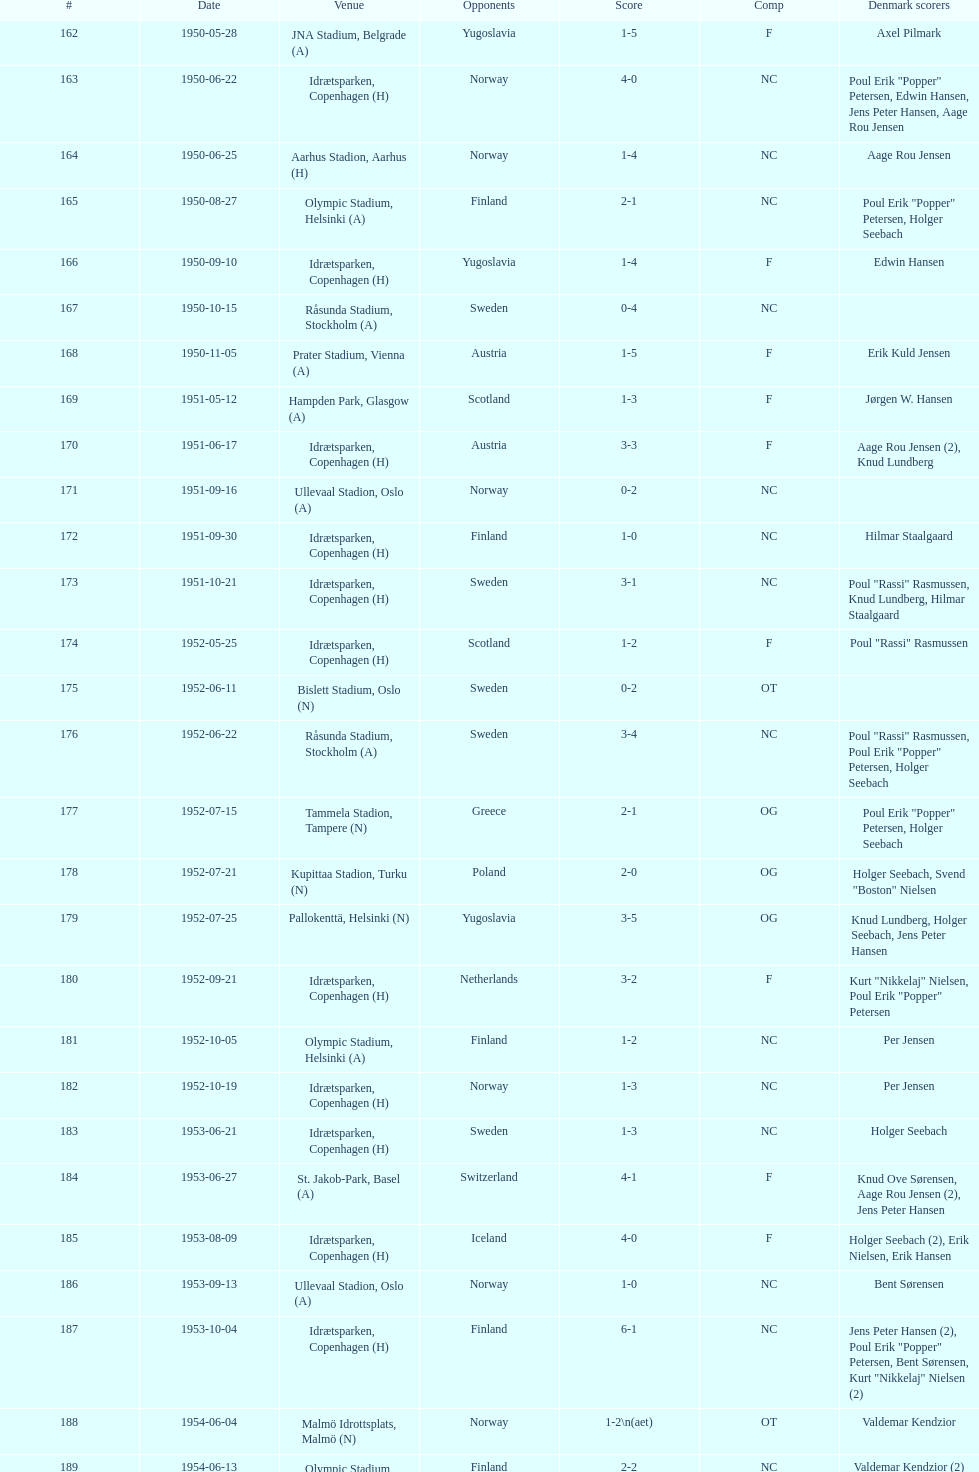What is the place just under jna stadium, belgrade (a)? Idrætsparken, Copenhagen (H). 